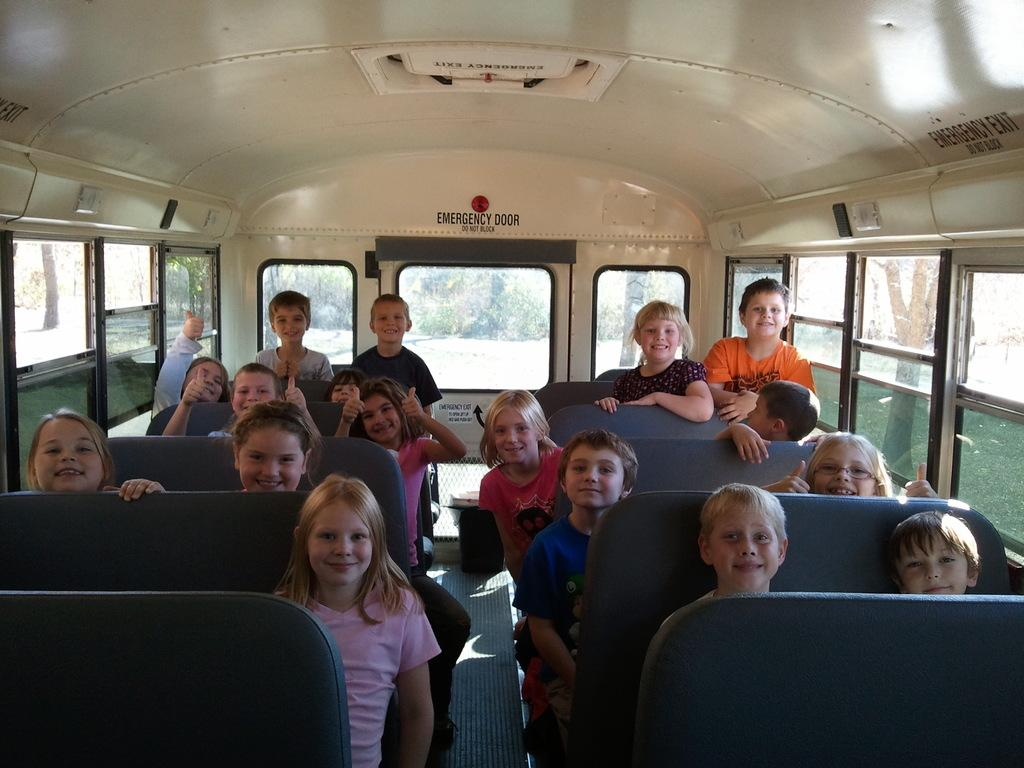What type of setting is depicted in the image? The image is an inside view of a vehicle. Who is present in the image? There are children in the image. What is the emotional state of the children? The children are smiling. How are the children positioned in the image? Some children are sitting. What else can be seen in the image besides the children? There is text visible in the image. What type of feather can be seen floating in the image? There is no feather present in the image; it is an inside view of a vehicle with children. 